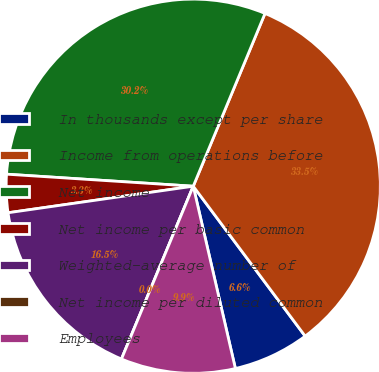Convert chart to OTSL. <chart><loc_0><loc_0><loc_500><loc_500><pie_chart><fcel>In thousands except per share<fcel>Income from operations before<fcel>Net income<fcel>Net income per basic common<fcel>Weighted-average number of<fcel>Net income per diluted common<fcel>Employees<nl><fcel>6.59%<fcel>33.53%<fcel>30.24%<fcel>3.29%<fcel>16.47%<fcel>0.0%<fcel>9.88%<nl></chart> 